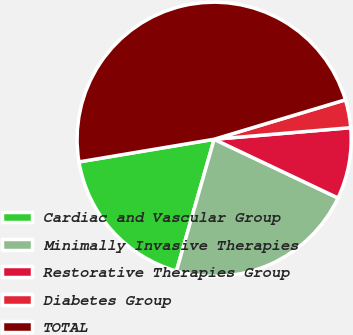<chart> <loc_0><loc_0><loc_500><loc_500><pie_chart><fcel>Cardiac and Vascular Group<fcel>Minimally Invasive Therapies<fcel>Restorative Therapies Group<fcel>Diabetes Group<fcel>TOTAL<nl><fcel>17.92%<fcel>22.39%<fcel>8.39%<fcel>3.3%<fcel>47.99%<nl></chart> 